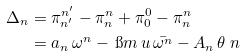<formula> <loc_0><loc_0><loc_500><loc_500>\Delta _ { n } & = \pi ^ { n ^ { \prime } } _ { n ^ { \prime } } - \pi ^ { n } _ { n } + \pi ^ { 0 } _ { 0 } - \pi ^ { n } _ { n } \\ & = a _ { n } \, \omega ^ { n } - \, \i m \, u \, \bar { \omega ^ { n } } - A _ { n } \, \theta \ n</formula> 